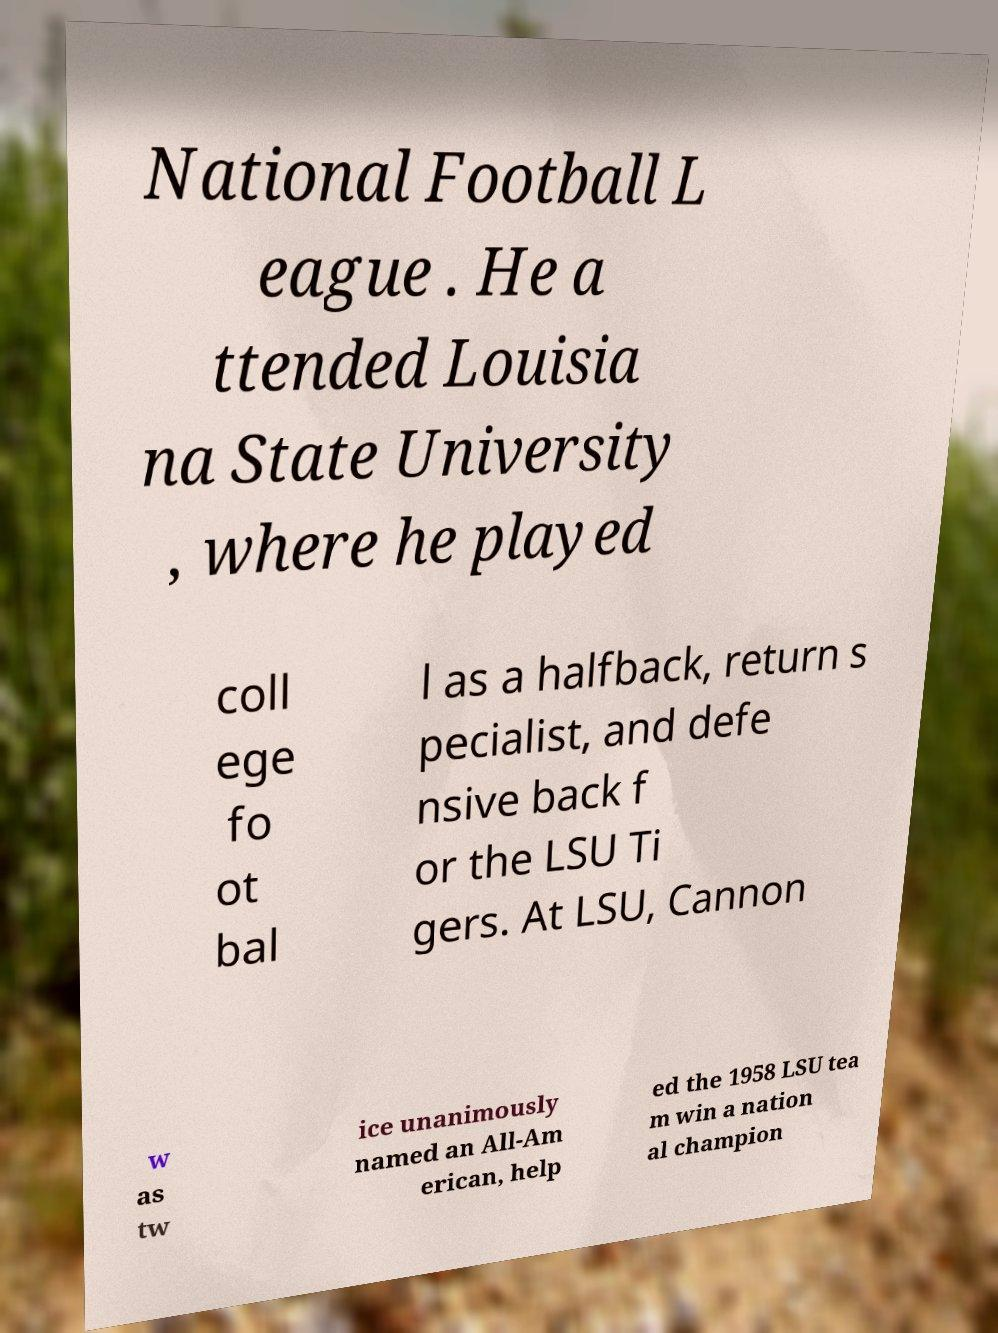Can you read and provide the text displayed in the image?This photo seems to have some interesting text. Can you extract and type it out for me? National Football L eague . He a ttended Louisia na State University , where he played coll ege fo ot bal l as a halfback, return s pecialist, and defe nsive back f or the LSU Ti gers. At LSU, Cannon w as tw ice unanimously named an All-Am erican, help ed the 1958 LSU tea m win a nation al champion 